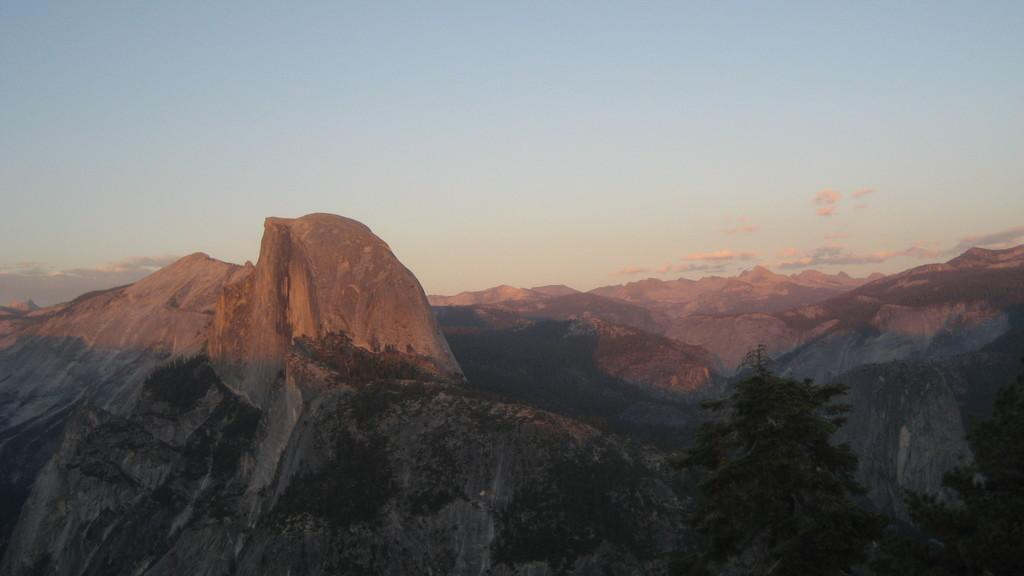What type of natural formation can be seen in the image? There are mountains in the image. What type of vegetation is present on the ground in the image? There are trees on the ground in the image. What is visible at the top of the image? The sky is visible at the top of the image. What is the condition of the sky in the image? The sky is cloudy in the image. Can you see any ghosts flying around the mountains in the image? There are no ghosts or any indication of flying objects in the image; it features mountains, trees, and a cloudy sky. 